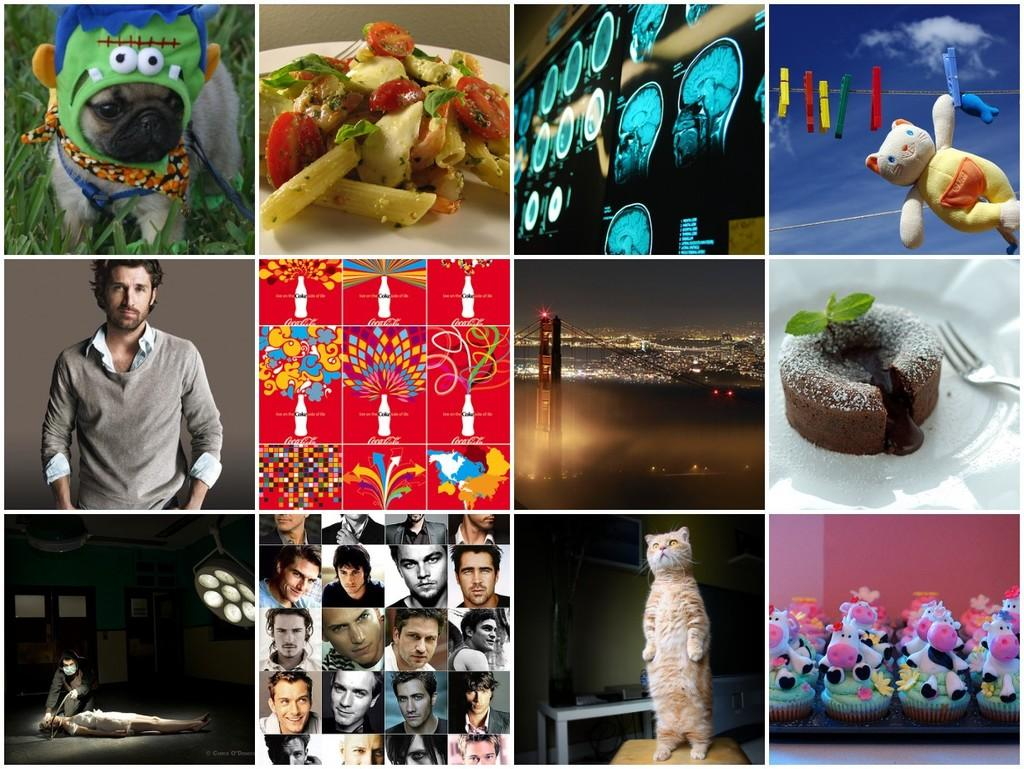What types of subjects are depicted in the images within the image? There are images of human beings, animals, toys, and a city in the image. Are there any decorative elements in the images? Yes, there are decorated pictures in the image. How many chairs are visible in the image? There are no chairs present in the image. What is the color of the minister's robe in the image? There is no minister present in the image. 